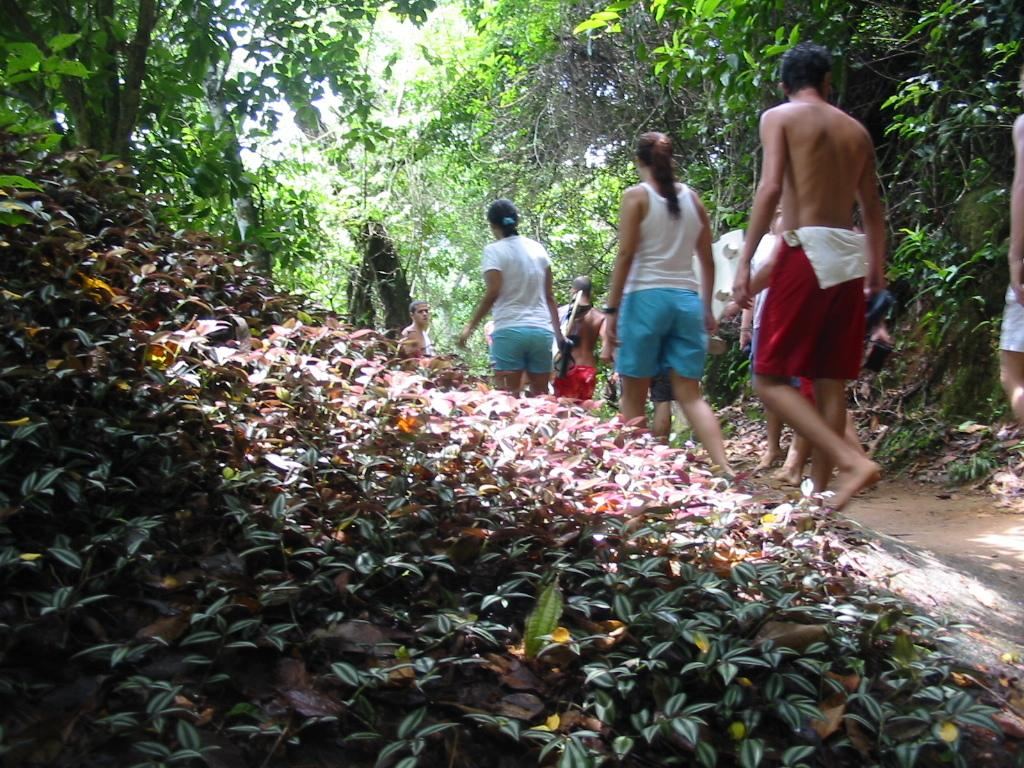What type of living organisms can be seen in the image? Plants can be seen in the image. Are there any people in the image? Yes, there are persons in the image. What are the persons wearing? The persons are wearing clothes. What are the persons doing in the image? The persons are walking on a path. What can be seen in the background of the image? There are trees at the top of the image. How many pizzas are being served to the women in the image? There are no pizzas or women present in the image. What type of industry can be seen in the background of the image? There is no industry visible in the image; it features plants, persons, and trees. 